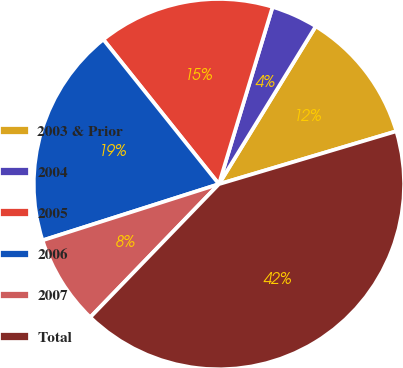Convert chart to OTSL. <chart><loc_0><loc_0><loc_500><loc_500><pie_chart><fcel>2003 & Prior<fcel>2004<fcel>2005<fcel>2006<fcel>2007<fcel>Total<nl><fcel>11.63%<fcel>4.08%<fcel>15.41%<fcel>19.18%<fcel>7.86%<fcel>41.84%<nl></chart> 